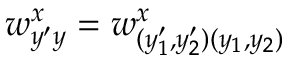<formula> <loc_0><loc_0><loc_500><loc_500>w _ { y ^ { \prime } y } ^ { x } = w _ { ( y _ { 1 } ^ { \prime } , y _ { 2 } ^ { \prime } ) ( y _ { 1 } , y _ { 2 } ) } ^ { x }</formula> 